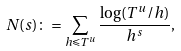<formula> <loc_0><loc_0><loc_500><loc_500>N ( s ) \colon = \sum _ { h \leqslant T ^ { u } } \frac { \log ( T ^ { u } / h ) } { h ^ { s } } ,</formula> 